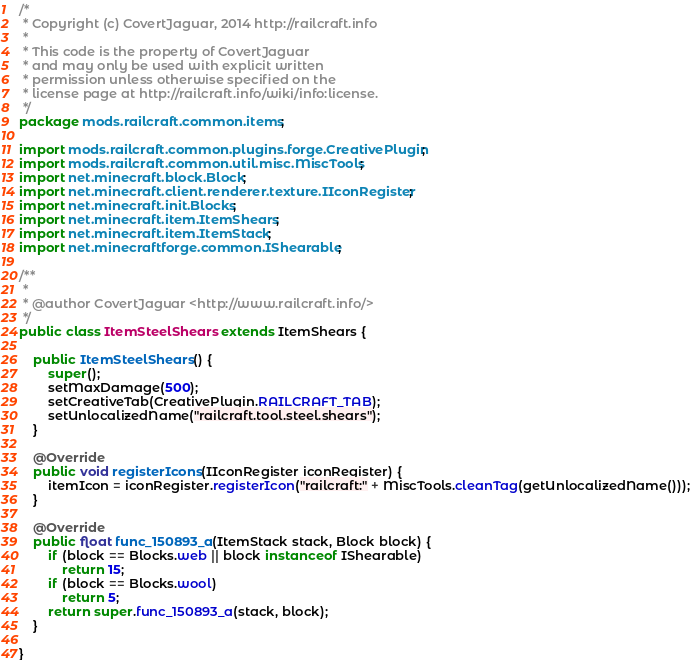Convert code to text. <code><loc_0><loc_0><loc_500><loc_500><_Java_>/* 
 * Copyright (c) CovertJaguar, 2014 http://railcraft.info
 * 
 * This code is the property of CovertJaguar
 * and may only be used with explicit written
 * permission unless otherwise specified on the
 * license page at http://railcraft.info/wiki/info:license.
 */
package mods.railcraft.common.items;

import mods.railcraft.common.plugins.forge.CreativePlugin;
import mods.railcraft.common.util.misc.MiscTools;
import net.minecraft.block.Block;
import net.minecraft.client.renderer.texture.IIconRegister;
import net.minecraft.init.Blocks;
import net.minecraft.item.ItemShears;
import net.minecraft.item.ItemStack;
import net.minecraftforge.common.IShearable;

/**
 *
 * @author CovertJaguar <http://www.railcraft.info/>
 */
public class ItemSteelShears extends ItemShears {

    public ItemSteelShears() {
        super();
        setMaxDamage(500);
        setCreativeTab(CreativePlugin.RAILCRAFT_TAB);
        setUnlocalizedName("railcraft.tool.steel.shears");
    }

    @Override
    public void registerIcons(IIconRegister iconRegister) {
        itemIcon = iconRegister.registerIcon("railcraft:" + MiscTools.cleanTag(getUnlocalizedName()));
    }

    @Override
    public float func_150893_a(ItemStack stack, Block block) {
        if (block == Blocks.web || block instanceof IShearable)
            return 15;
        if (block == Blocks.wool)
            return 5;
        return super.func_150893_a(stack, block);
    }

}
</code> 